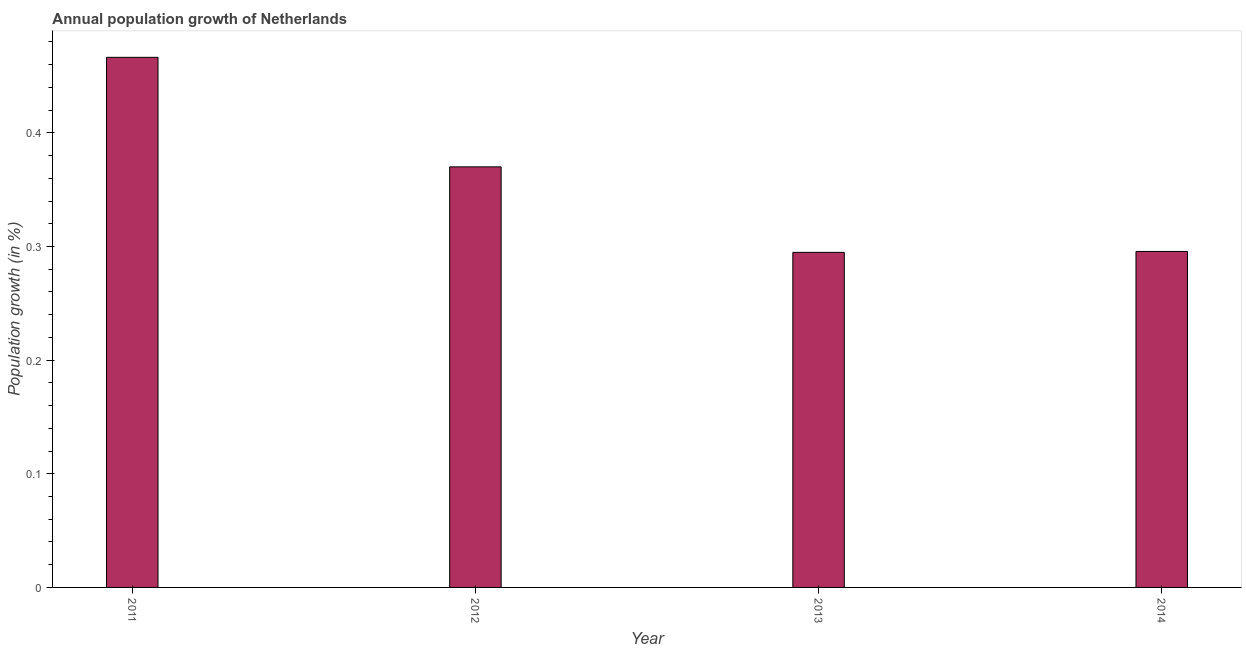What is the title of the graph?
Provide a short and direct response. Annual population growth of Netherlands. What is the label or title of the X-axis?
Offer a very short reply. Year. What is the label or title of the Y-axis?
Your response must be concise. Population growth (in %). What is the population growth in 2012?
Your answer should be compact. 0.37. Across all years, what is the maximum population growth?
Your answer should be compact. 0.47. Across all years, what is the minimum population growth?
Offer a terse response. 0.29. In which year was the population growth maximum?
Give a very brief answer. 2011. In which year was the population growth minimum?
Provide a succinct answer. 2013. What is the sum of the population growth?
Give a very brief answer. 1.43. What is the difference between the population growth in 2012 and 2013?
Your answer should be very brief. 0.07. What is the average population growth per year?
Your answer should be very brief. 0.36. What is the median population growth?
Make the answer very short. 0.33. Is the population growth in 2013 less than that in 2014?
Keep it short and to the point. Yes. Is the difference between the population growth in 2012 and 2013 greater than the difference between any two years?
Provide a short and direct response. No. What is the difference between the highest and the second highest population growth?
Your response must be concise. 0.1. What is the difference between the highest and the lowest population growth?
Your answer should be very brief. 0.17. In how many years, is the population growth greater than the average population growth taken over all years?
Give a very brief answer. 2. Are all the bars in the graph horizontal?
Make the answer very short. No. What is the difference between two consecutive major ticks on the Y-axis?
Give a very brief answer. 0.1. Are the values on the major ticks of Y-axis written in scientific E-notation?
Your response must be concise. No. What is the Population growth (in %) in 2011?
Provide a succinct answer. 0.47. What is the Population growth (in %) of 2012?
Your answer should be very brief. 0.37. What is the Population growth (in %) of 2013?
Provide a short and direct response. 0.29. What is the Population growth (in %) of 2014?
Ensure brevity in your answer.  0.3. What is the difference between the Population growth (in %) in 2011 and 2012?
Offer a terse response. 0.1. What is the difference between the Population growth (in %) in 2011 and 2013?
Ensure brevity in your answer.  0.17. What is the difference between the Population growth (in %) in 2011 and 2014?
Your response must be concise. 0.17. What is the difference between the Population growth (in %) in 2012 and 2013?
Your answer should be very brief. 0.08. What is the difference between the Population growth (in %) in 2012 and 2014?
Provide a short and direct response. 0.07. What is the difference between the Population growth (in %) in 2013 and 2014?
Give a very brief answer. -0. What is the ratio of the Population growth (in %) in 2011 to that in 2012?
Ensure brevity in your answer.  1.26. What is the ratio of the Population growth (in %) in 2011 to that in 2013?
Your answer should be very brief. 1.58. What is the ratio of the Population growth (in %) in 2011 to that in 2014?
Keep it short and to the point. 1.58. What is the ratio of the Population growth (in %) in 2012 to that in 2013?
Your answer should be very brief. 1.25. What is the ratio of the Population growth (in %) in 2012 to that in 2014?
Provide a succinct answer. 1.25. What is the ratio of the Population growth (in %) in 2013 to that in 2014?
Provide a short and direct response. 1. 